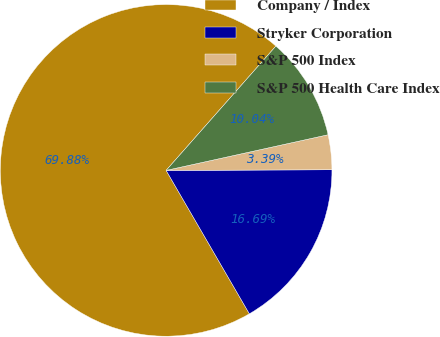Convert chart to OTSL. <chart><loc_0><loc_0><loc_500><loc_500><pie_chart><fcel>Company / Index<fcel>Stryker Corporation<fcel>S&P 500 Index<fcel>S&P 500 Health Care Index<nl><fcel>69.89%<fcel>16.69%<fcel>3.39%<fcel>10.04%<nl></chart> 